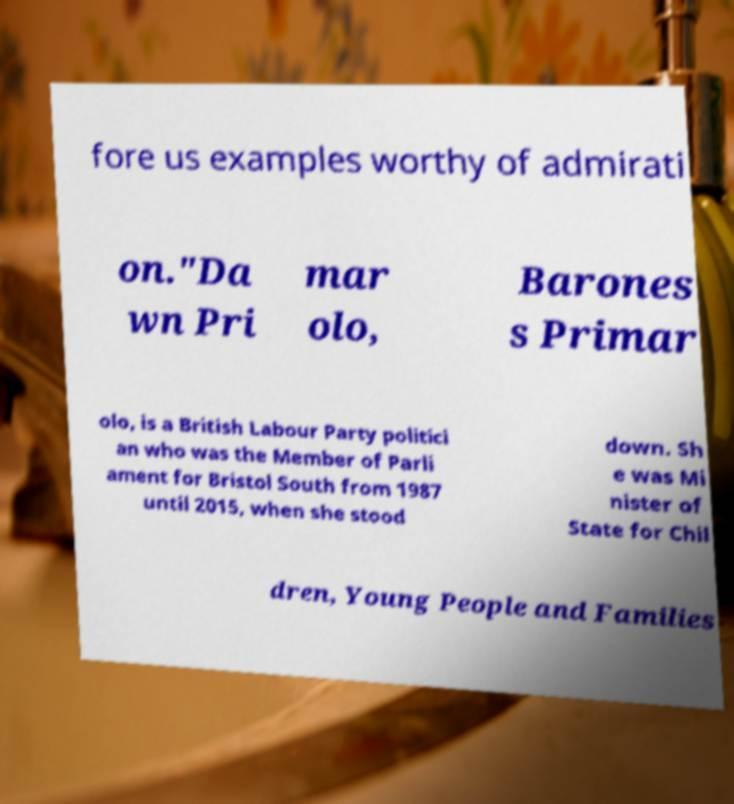Can you accurately transcribe the text from the provided image for me? fore us examples worthy of admirati on."Da wn Pri mar olo, Barones s Primar olo, is a British Labour Party politici an who was the Member of Parli ament for Bristol South from 1987 until 2015, when she stood down. Sh e was Mi nister of State for Chil dren, Young People and Families 